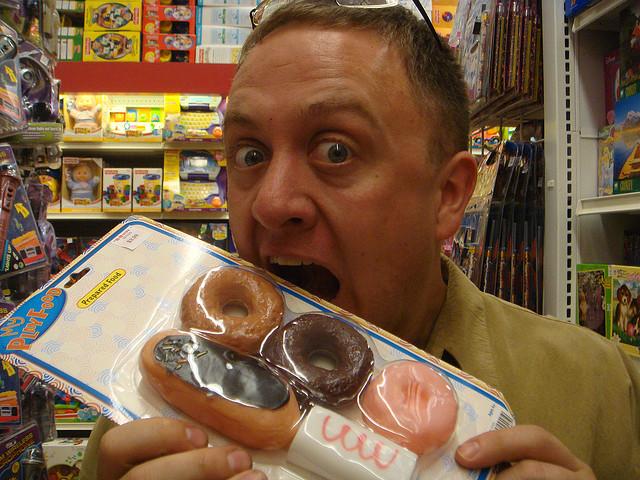How many doughnuts are there?
Quick response, please. 5. Does this man wear glasses?
Write a very short answer. No. Is this food?
Write a very short answer. No. 